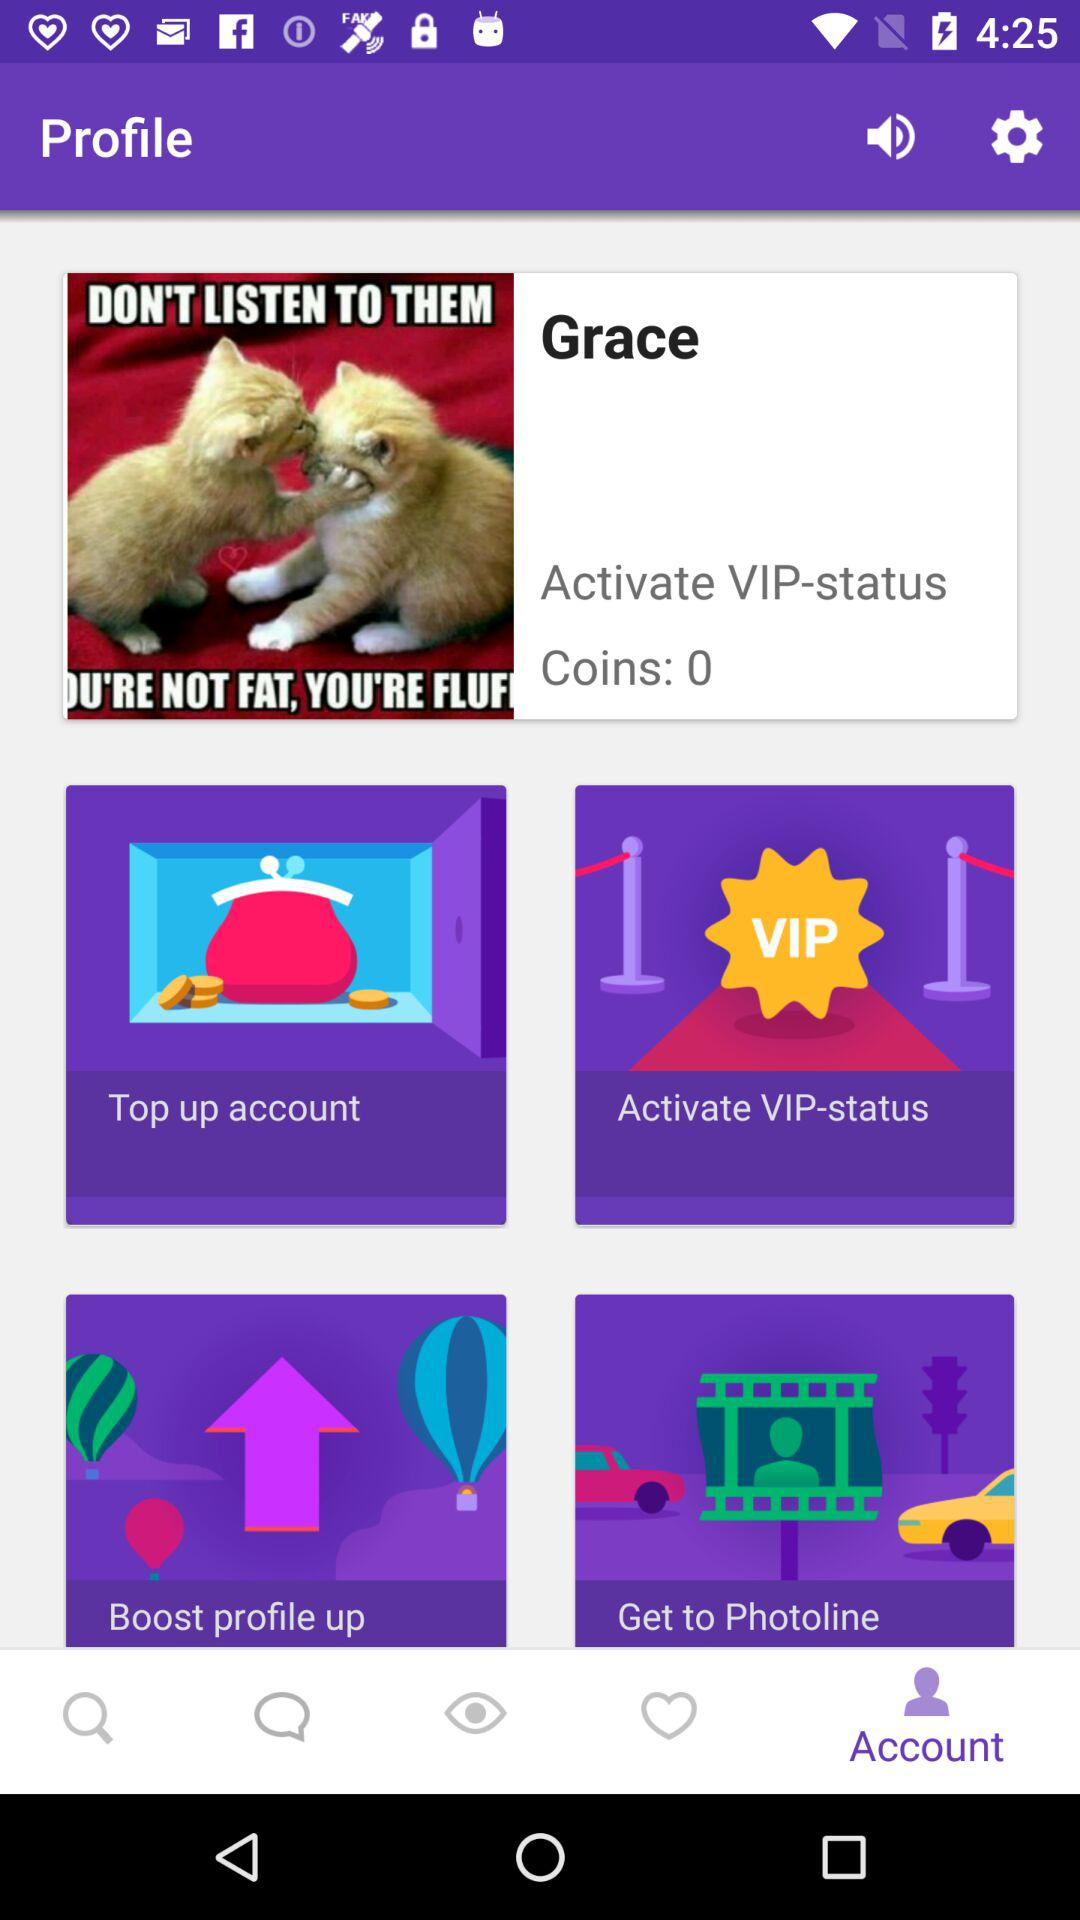What is the active status?
When the provided information is insufficient, respond with <no answer>. <no answer> 